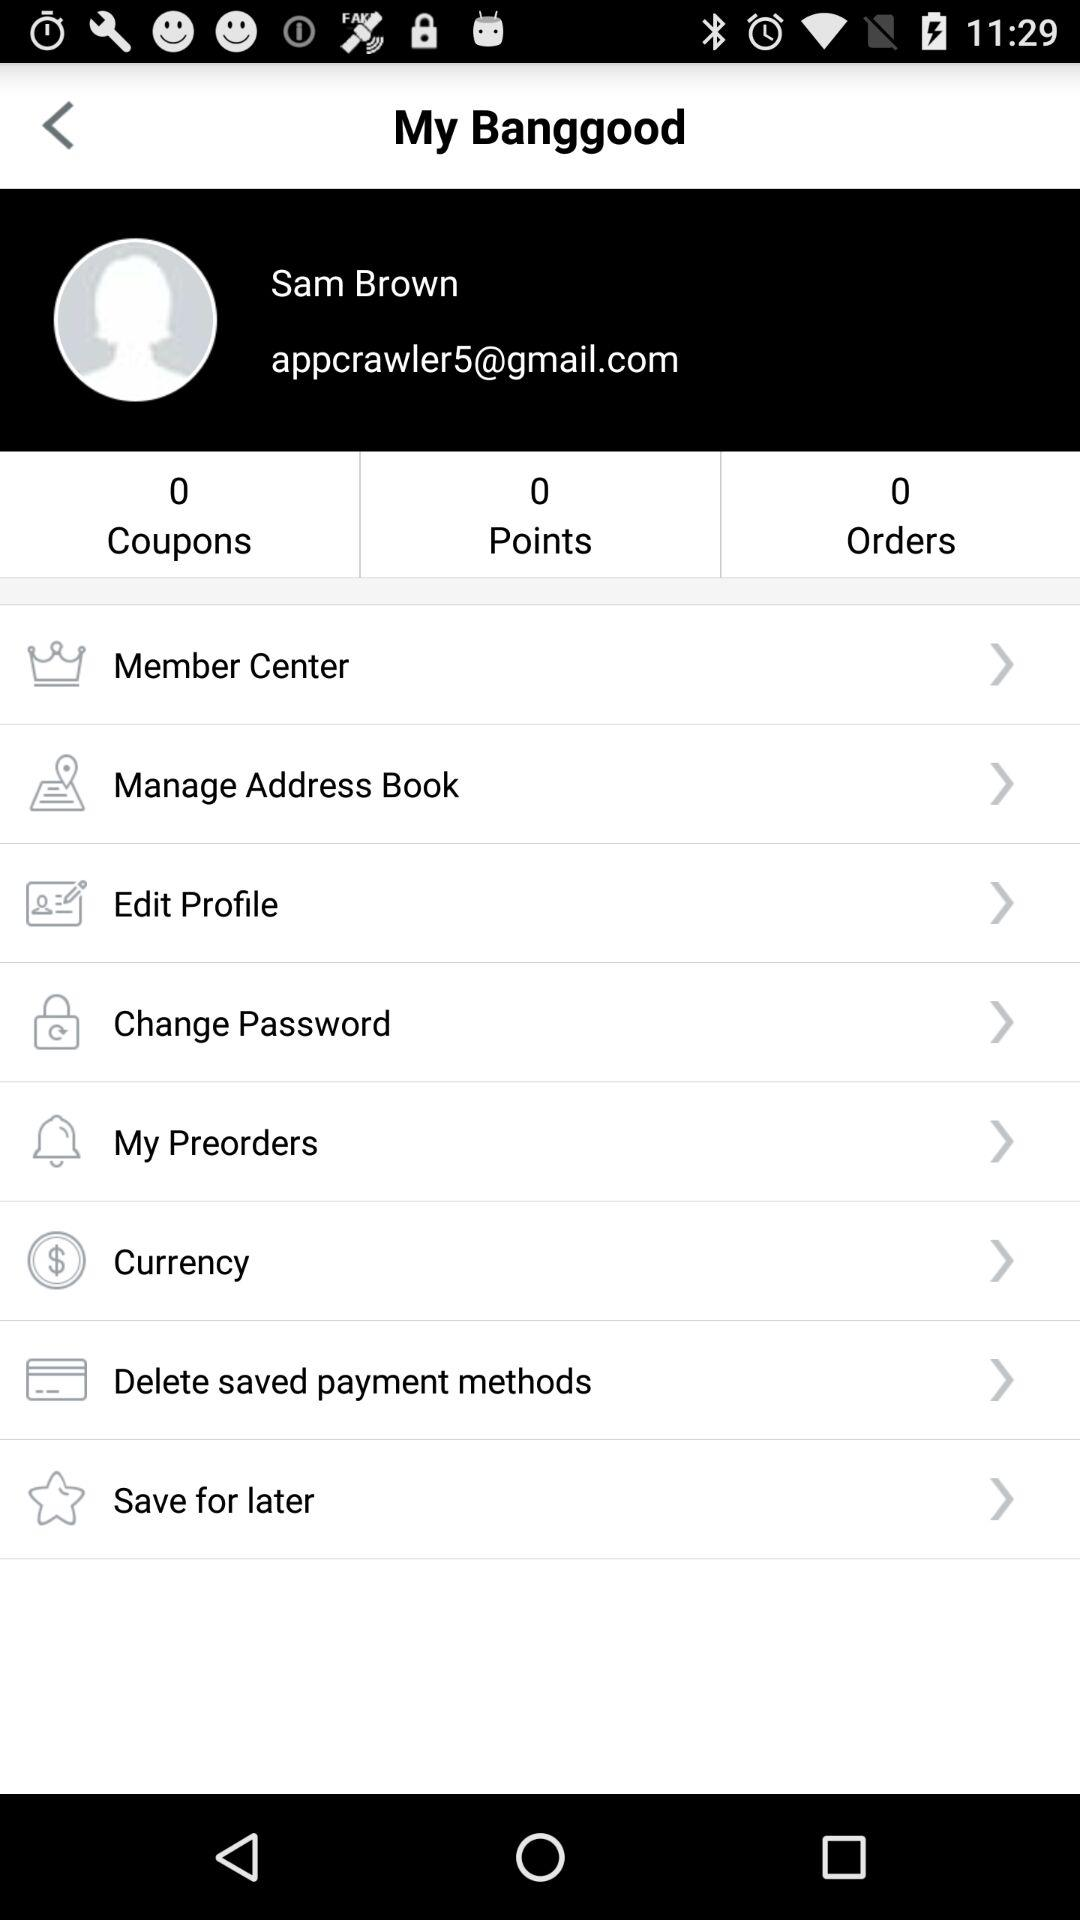What is the order count? The count is 0. 